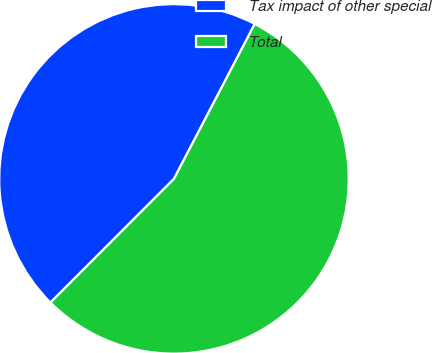Convert chart to OTSL. <chart><loc_0><loc_0><loc_500><loc_500><pie_chart><fcel>Tax impact of other special<fcel>Total<nl><fcel>45.16%<fcel>54.84%<nl></chart> 